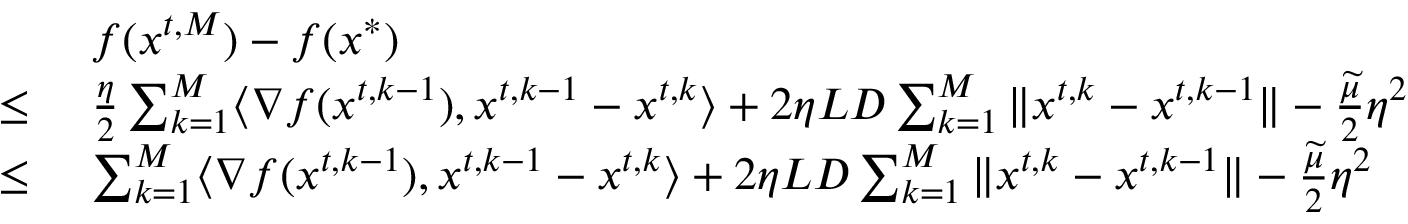Convert formula to latex. <formula><loc_0><loc_0><loc_500><loc_500>\begin{array} { r l } & { f ( { x } ^ { t , M } ) - f ( { x } ^ { * } ) } \\ { \leq \ } & { \frac { \eta } { 2 } \sum _ { k = 1 } ^ { M } \langle \nabla f ( { x } ^ { t , k - 1 } ) , { x } ^ { t , k - 1 } - { x } ^ { t , k } \rangle + 2 \eta L D \sum _ { k = 1 } ^ { M } \| { x } ^ { t , k } - { x } ^ { t , k - 1 } \| - \frac { \widetilde { \mu } } { 2 } \eta ^ { 2 } } \\ { \leq \ } & { \sum _ { k = 1 } ^ { M } \langle \nabla f ( { x } ^ { t , k - 1 } ) , { x } ^ { t , k - 1 } - { x } ^ { t , k } \rangle + 2 \eta L D \sum _ { k = 1 } ^ { M } \| { x } ^ { t , k } - { x } ^ { t , k - 1 } \| - \frac { \widetilde { \mu } } { 2 } \eta ^ { 2 } } \end{array}</formula> 